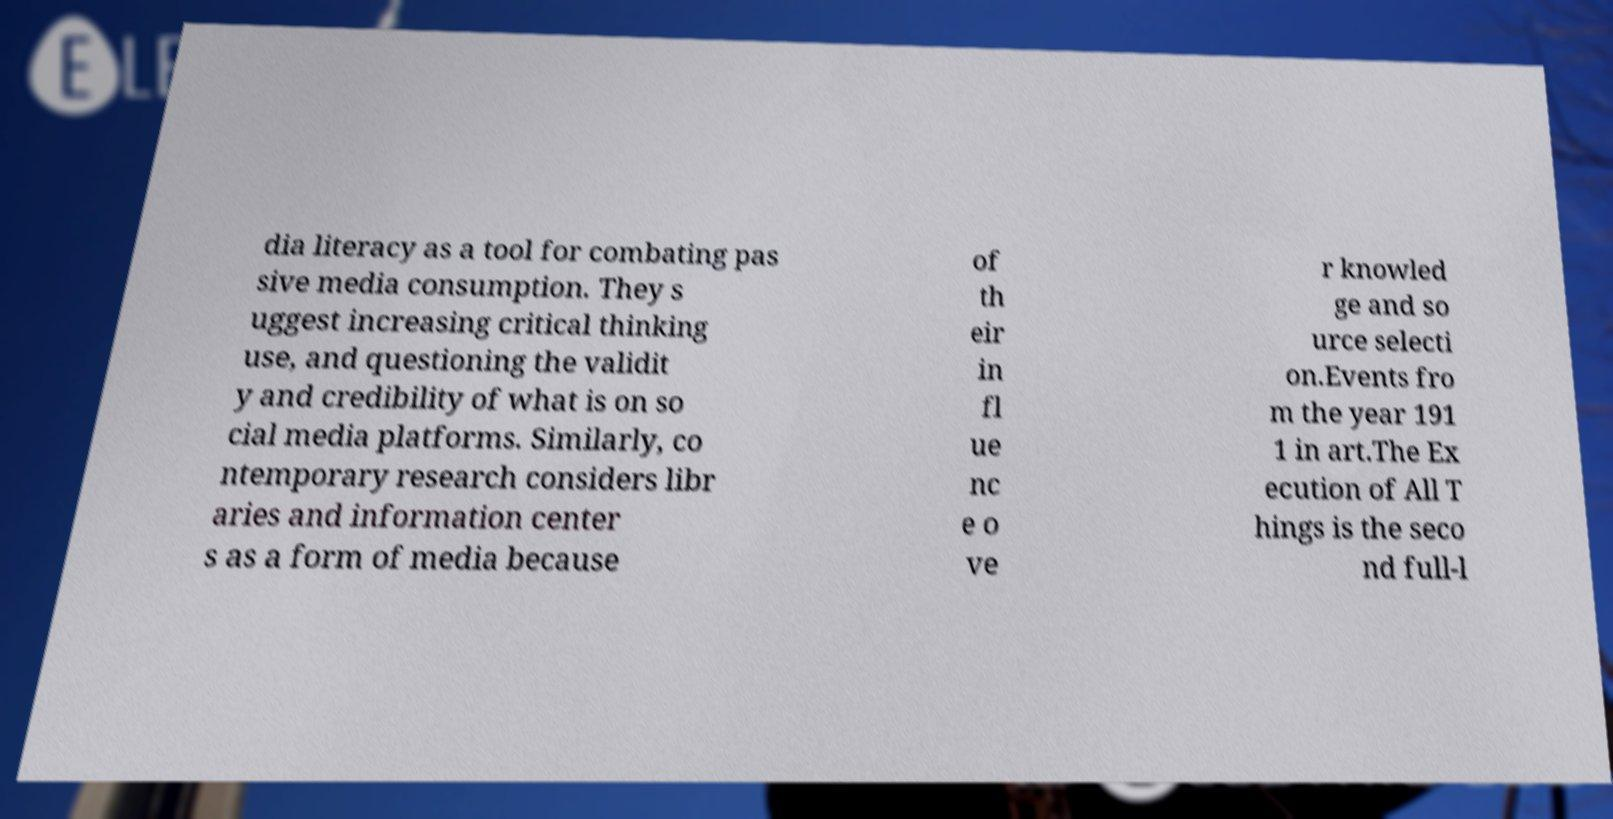Please identify and transcribe the text found in this image. dia literacy as a tool for combating pas sive media consumption. They s uggest increasing critical thinking use, and questioning the validit y and credibility of what is on so cial media platforms. Similarly, co ntemporary research considers libr aries and information center s as a form of media because of th eir in fl ue nc e o ve r knowled ge and so urce selecti on.Events fro m the year 191 1 in art.The Ex ecution of All T hings is the seco nd full-l 